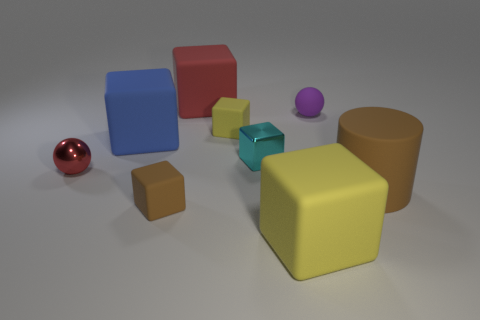Subtract all gray cylinders. How many yellow cubes are left? 2 Subtract all tiny cyan blocks. How many blocks are left? 5 Subtract all red blocks. How many blocks are left? 5 Subtract 1 cubes. How many cubes are left? 5 Subtract all green blocks. Subtract all green balls. How many blocks are left? 6 Subtract all blocks. How many objects are left? 3 Add 6 tiny cyan metal cubes. How many tiny cyan metal cubes are left? 7 Add 4 brown matte cubes. How many brown matte cubes exist? 5 Subtract 1 brown cylinders. How many objects are left? 8 Subtract all small yellow shiny spheres. Subtract all cylinders. How many objects are left? 8 